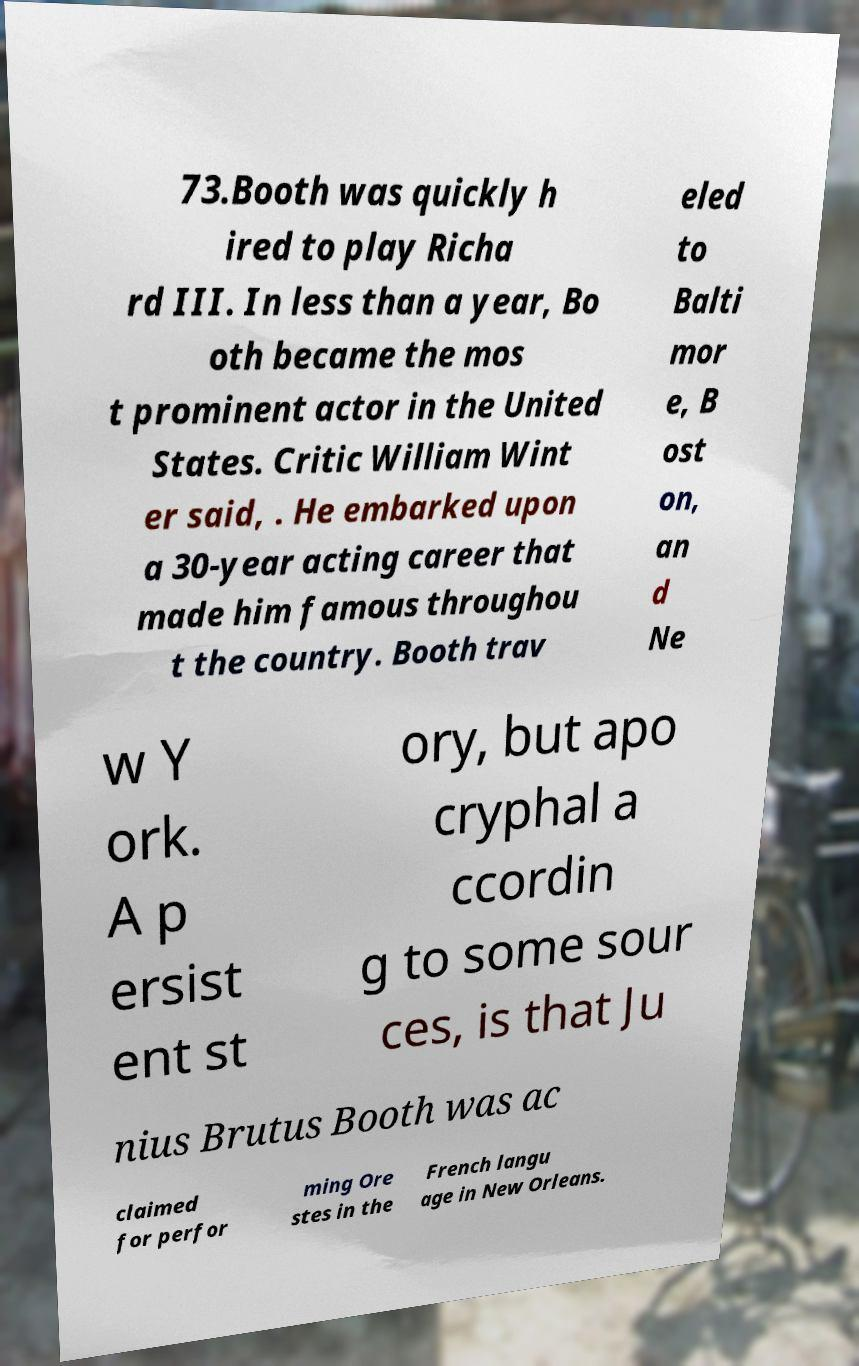Could you extract and type out the text from this image? 73.Booth was quickly h ired to play Richa rd III. In less than a year, Bo oth became the mos t prominent actor in the United States. Critic William Wint er said, . He embarked upon a 30-year acting career that made him famous throughou t the country. Booth trav eled to Balti mor e, B ost on, an d Ne w Y ork. A p ersist ent st ory, but apo cryphal a ccordin g to some sour ces, is that Ju nius Brutus Booth was ac claimed for perfor ming Ore stes in the French langu age in New Orleans. 